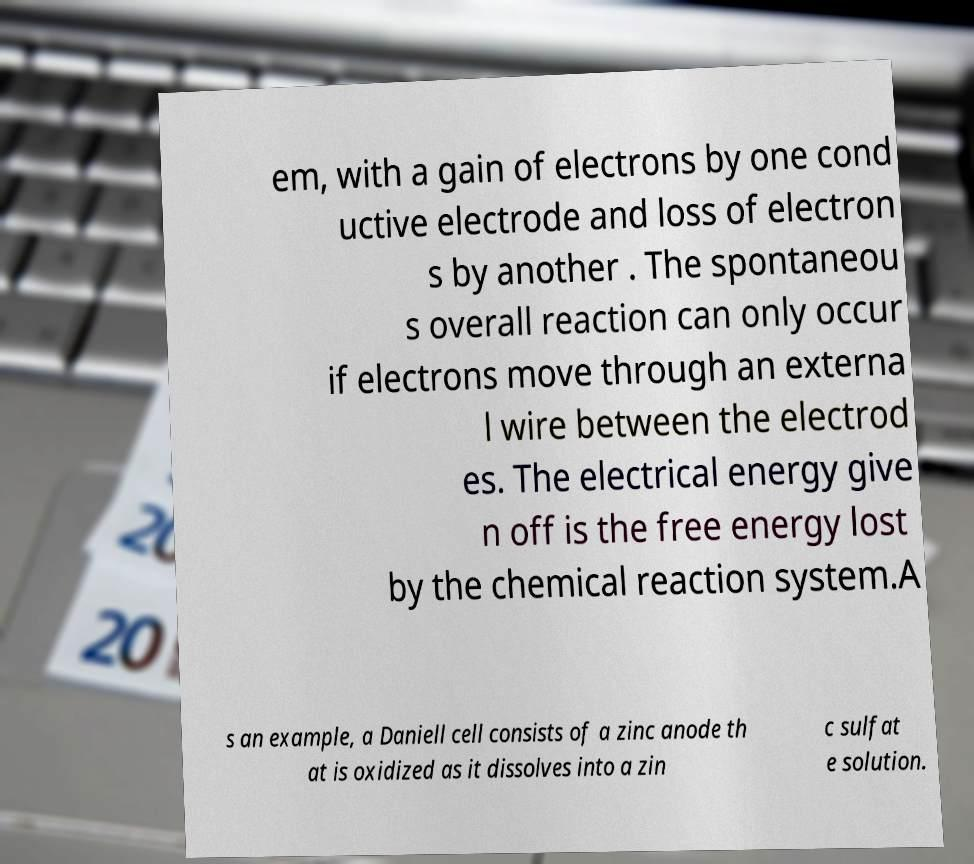Please read and relay the text visible in this image. What does it say? em, with a gain of electrons by one cond uctive electrode and loss of electron s by another . The spontaneou s overall reaction can only occur if electrons move through an externa l wire between the electrod es. The electrical energy give n off is the free energy lost by the chemical reaction system.A s an example, a Daniell cell consists of a zinc anode th at is oxidized as it dissolves into a zin c sulfat e solution. 